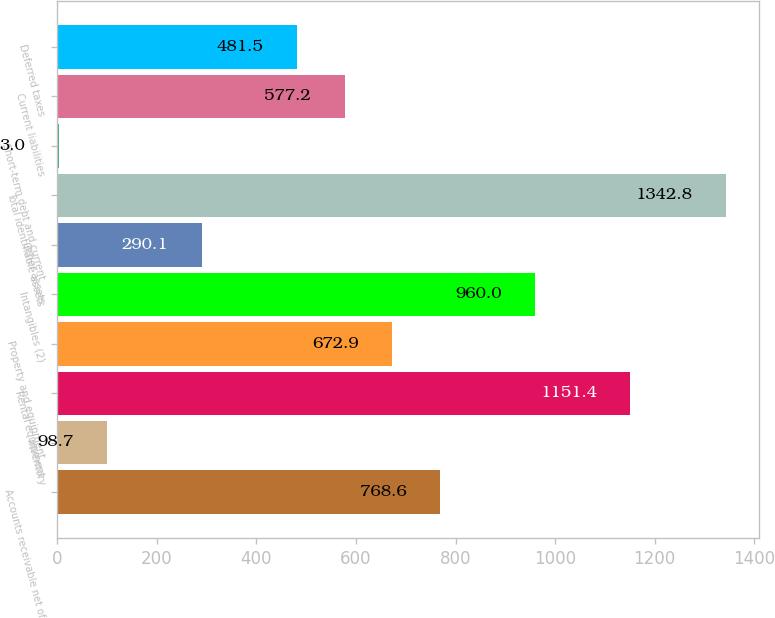Convert chart to OTSL. <chart><loc_0><loc_0><loc_500><loc_500><bar_chart><fcel>Accounts receivable net of<fcel>Inventory<fcel>Rental equipment<fcel>Property and equipment<fcel>Intangibles (2)<fcel>Other assets<fcel>Total identifiable assets<fcel>Short-term debt and current<fcel>Current liabilities<fcel>Deferred taxes<nl><fcel>768.6<fcel>98.7<fcel>1151.4<fcel>672.9<fcel>960<fcel>290.1<fcel>1342.8<fcel>3<fcel>577.2<fcel>481.5<nl></chart> 